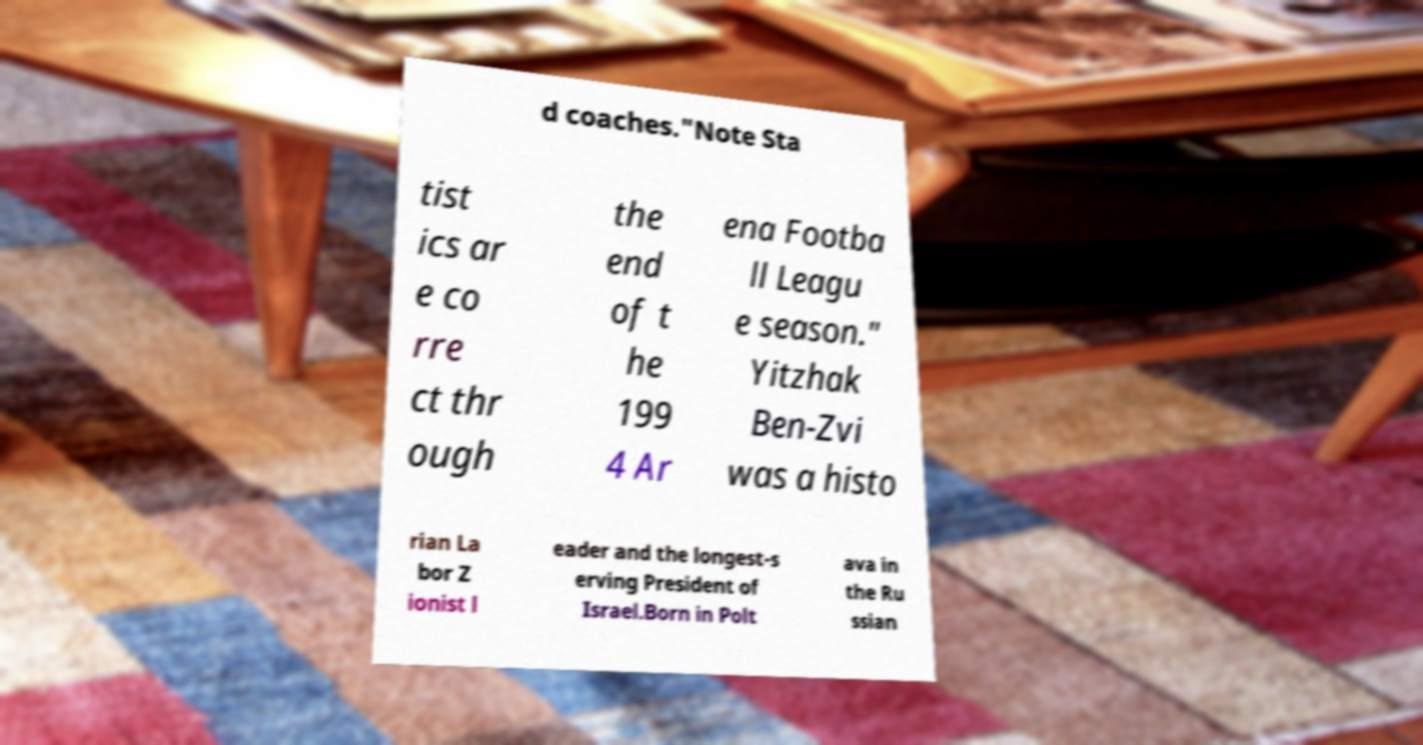Please identify and transcribe the text found in this image. d coaches."Note Sta tist ics ar e co rre ct thr ough the end of t he 199 4 Ar ena Footba ll Leagu e season." Yitzhak Ben-Zvi was a histo rian La bor Z ionist l eader and the longest-s erving President of Israel.Born in Polt ava in the Ru ssian 